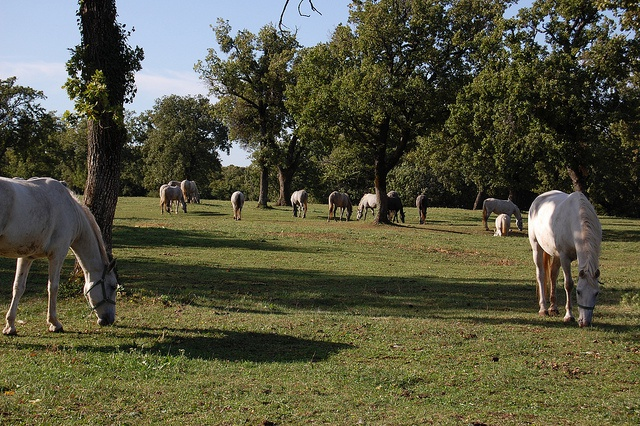Describe the objects in this image and their specific colors. I can see horse in lavender, black, gray, and darkgreen tones, horse in lavender, gray, black, and white tones, horse in lavender, black, gray, and maroon tones, horse in lavender, black, gray, and olive tones, and horse in lavender, black, gray, and olive tones in this image. 